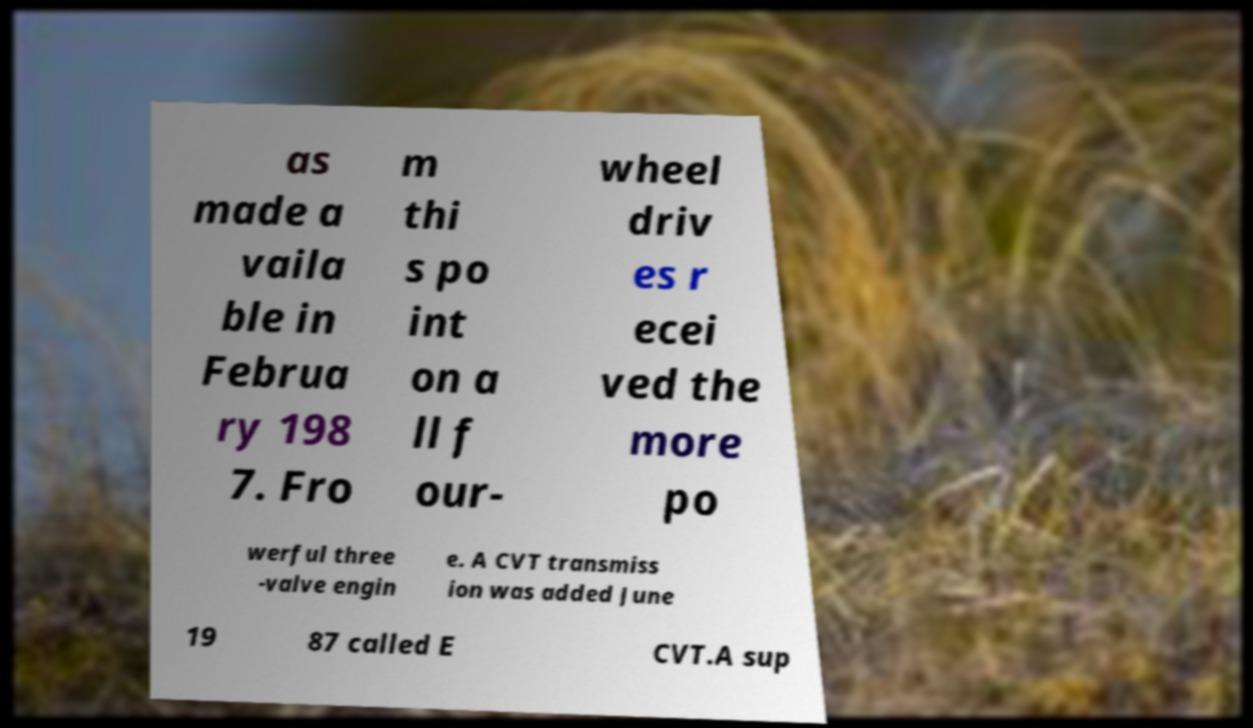Can you read and provide the text displayed in the image?This photo seems to have some interesting text. Can you extract and type it out for me? as made a vaila ble in Februa ry 198 7. Fro m thi s po int on a ll f our- wheel driv es r ecei ved the more po werful three -valve engin e. A CVT transmiss ion was added June 19 87 called E CVT.A sup 